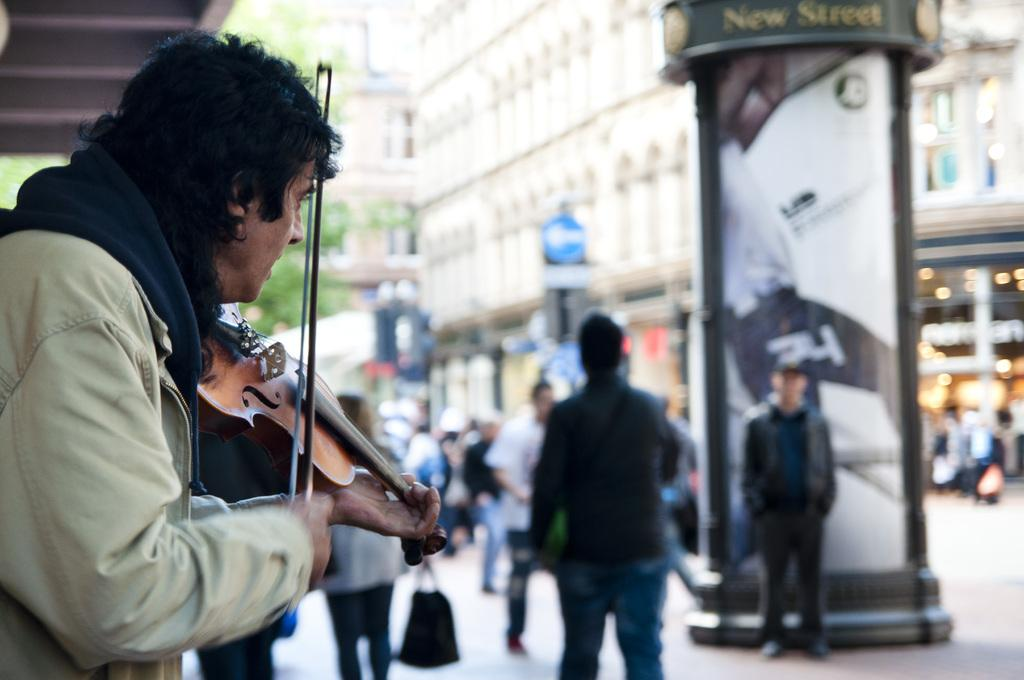What are the people in the image doing? The people in the image are standing on the road. Is there anyone in the image performing an activity? Yes, there is a person playing the guitar in the image. What can be seen in the background of the image? There is a building and a tree in the background of the image. What type of wire can be seen connecting the guitar to the building in the image? There is no wire connecting the guitar to the building in the image. Can you describe the garden in the image? There is no garden present in the image. 